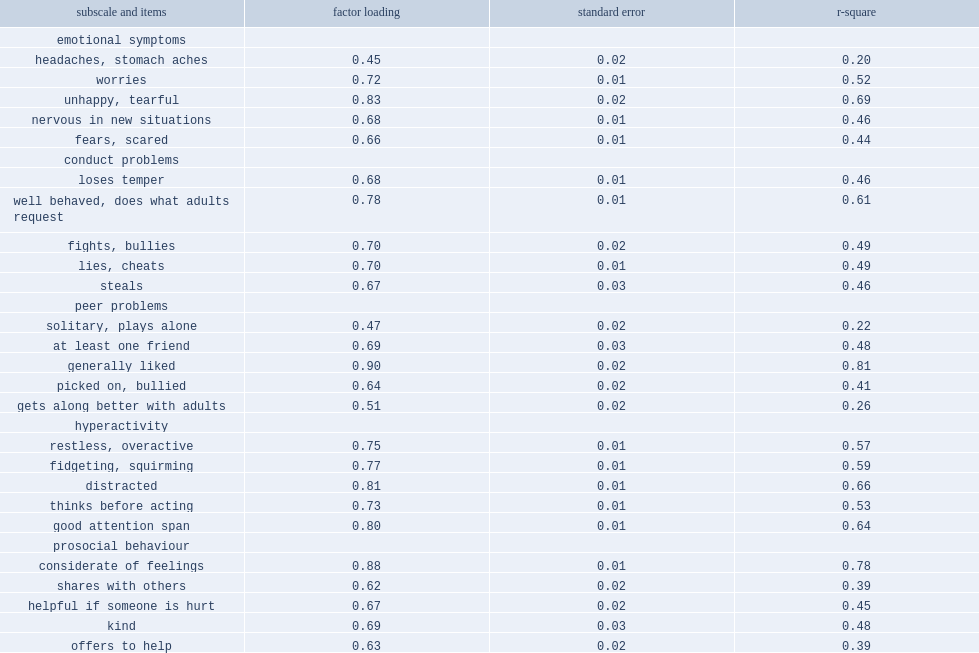What is the maximum and minimum of all standardized factor loadings for the five-factor model? 0.9 0.45. What is the minimum of all five factors' composite reliability? Peer problems. 